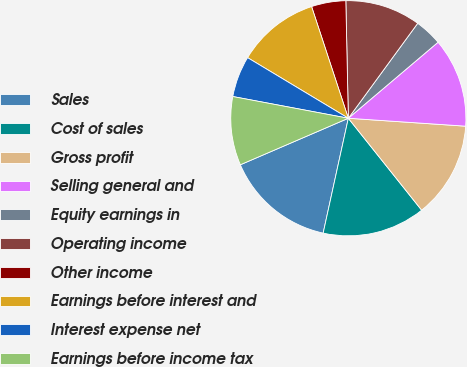Convert chart. <chart><loc_0><loc_0><loc_500><loc_500><pie_chart><fcel>Sales<fcel>Cost of sales<fcel>Gross profit<fcel>Selling general and<fcel>Equity earnings in<fcel>Operating income<fcel>Other income<fcel>Earnings before interest and<fcel>Interest expense net<fcel>Earnings before income tax<nl><fcel>15.09%<fcel>14.15%<fcel>13.21%<fcel>12.26%<fcel>3.77%<fcel>10.38%<fcel>4.72%<fcel>11.32%<fcel>5.66%<fcel>9.43%<nl></chart> 